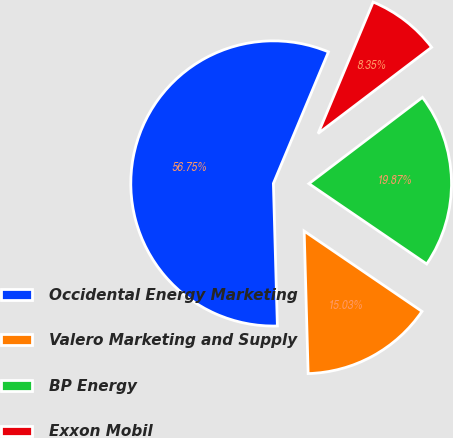Convert chart to OTSL. <chart><loc_0><loc_0><loc_500><loc_500><pie_chart><fcel>Occidental Energy Marketing<fcel>Valero Marketing and Supply<fcel>BP Energy<fcel>Exxon Mobil<nl><fcel>56.76%<fcel>15.03%<fcel>19.87%<fcel>8.35%<nl></chart> 